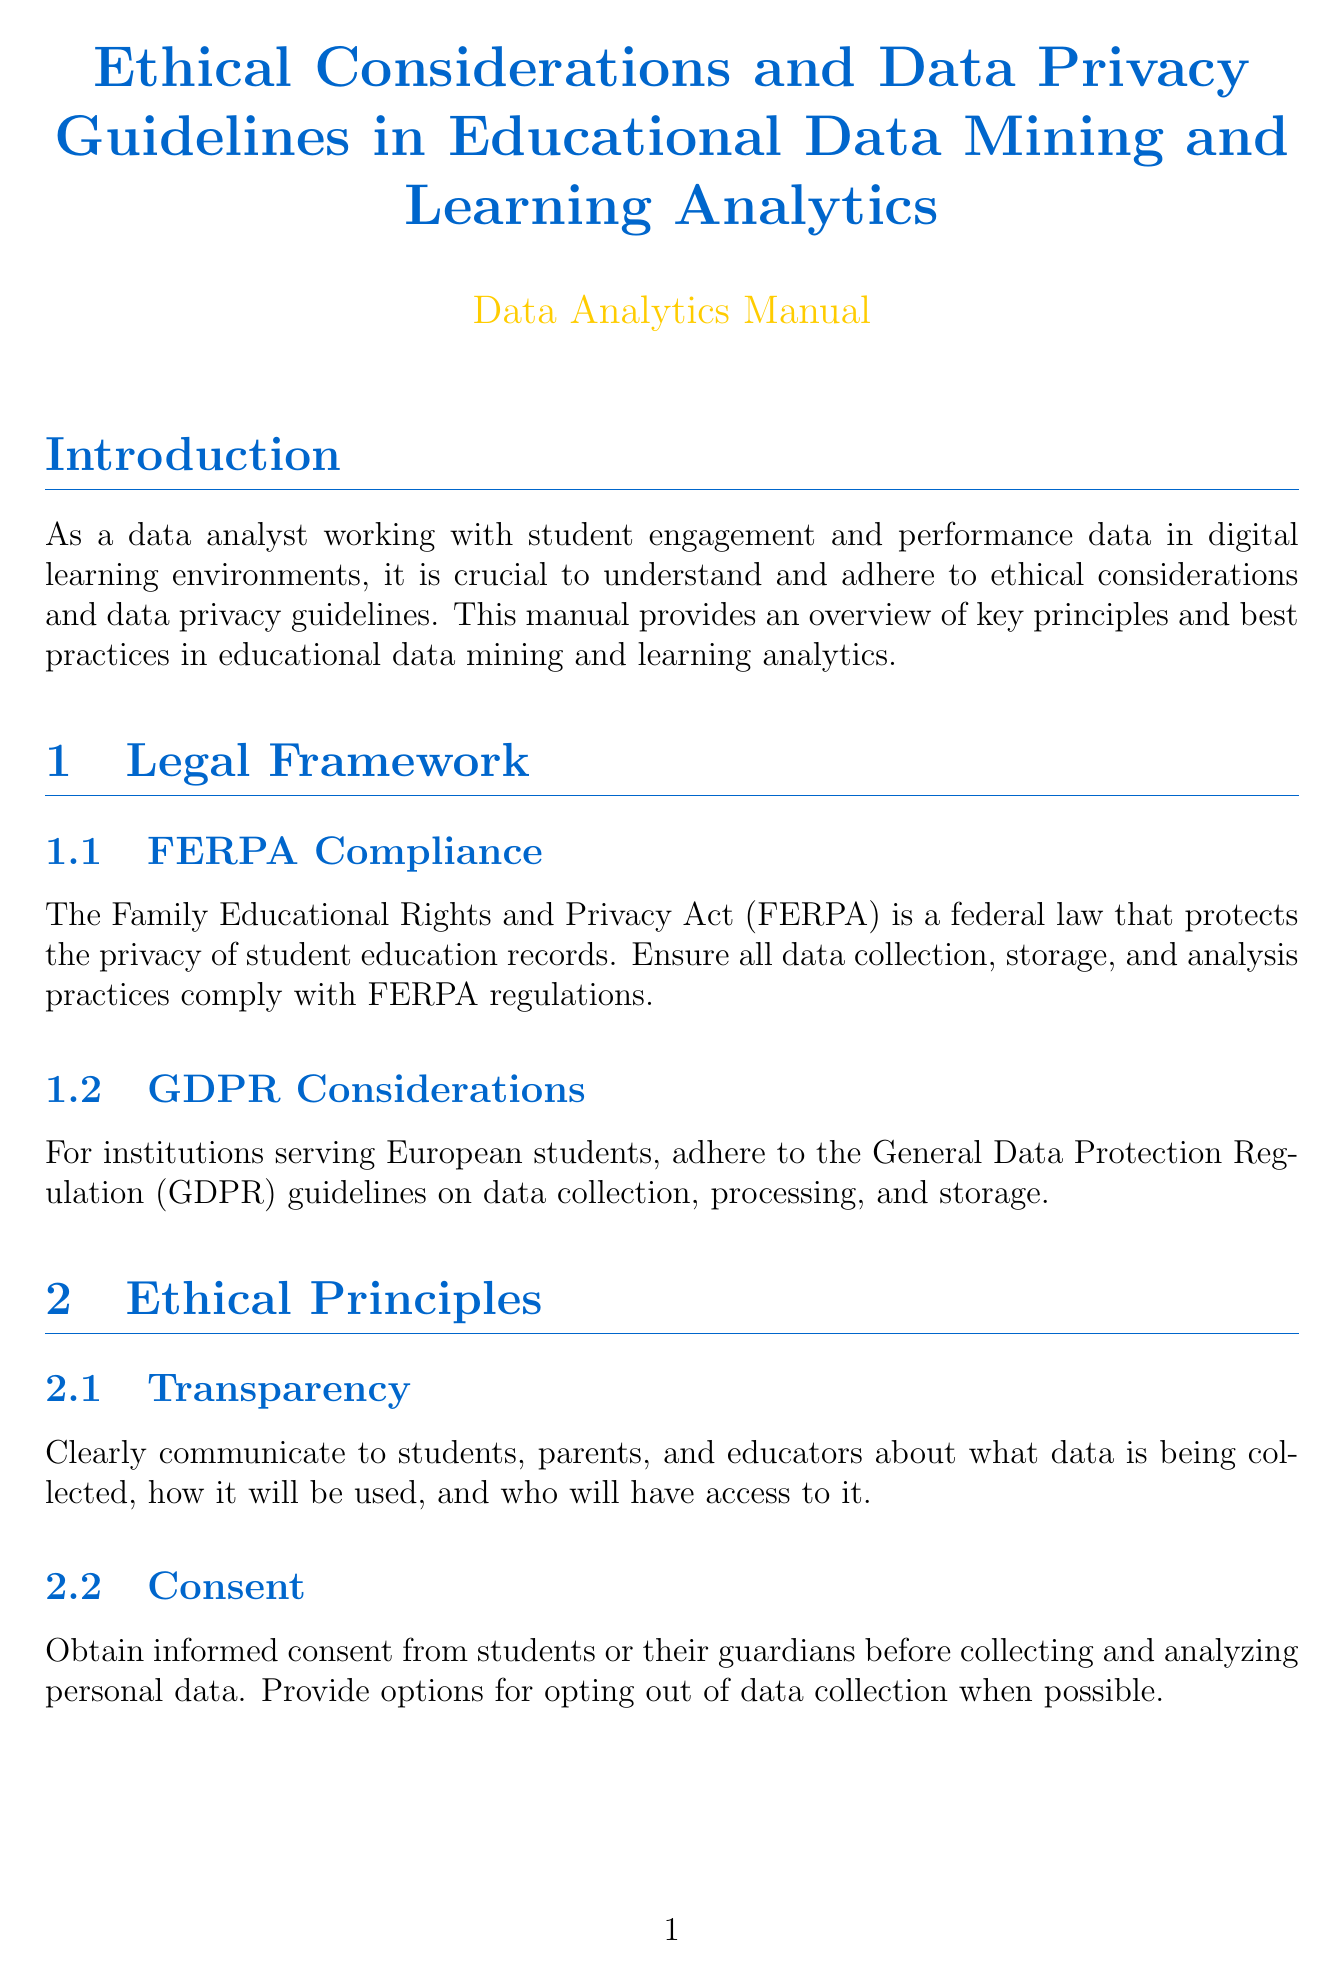What is the title of the manual? The title of the manual is explicitly stated at the beginning of the document.
Answer: Ethical Considerations and Data Privacy Guidelines in Educational Data Mining and Learning Analytics What does FERPA stand for? The abbreviation FERPA is defined in the Legal Framework section of the document.
Answer: Family Educational Rights and Privacy Act What are the two main legal frameworks mentioned? The document outlines these frameworks in the Legal Framework section, which includes two subsections.
Answer: FERPA and GDPR What principle requires informed consent? This principle is explicitly named in the Ethical Principles section of the document.
Answer: Consent What encryption standard is recommended? The suggested encryption method is stated in the Data Security Measures section of the document.
Answer: AES-256 What should be established for data retention? This policy is discussed in the Data Retention and Deletion section of the document.
Answer: Clear policies Which term is used to describe the practice of protecting individual identities? This concept is defined in its own section within the document.
Answer: Anonymization What type of control is recommended for data access? This recommendation is found in the Data Security Measures section regarding protecting sensitive data.
Answer: Role-based access control Who must be audited regularly for bias? The document specifies the subject that requires auditing in the Bias and Fairness section.
Answer: Machine learning models 